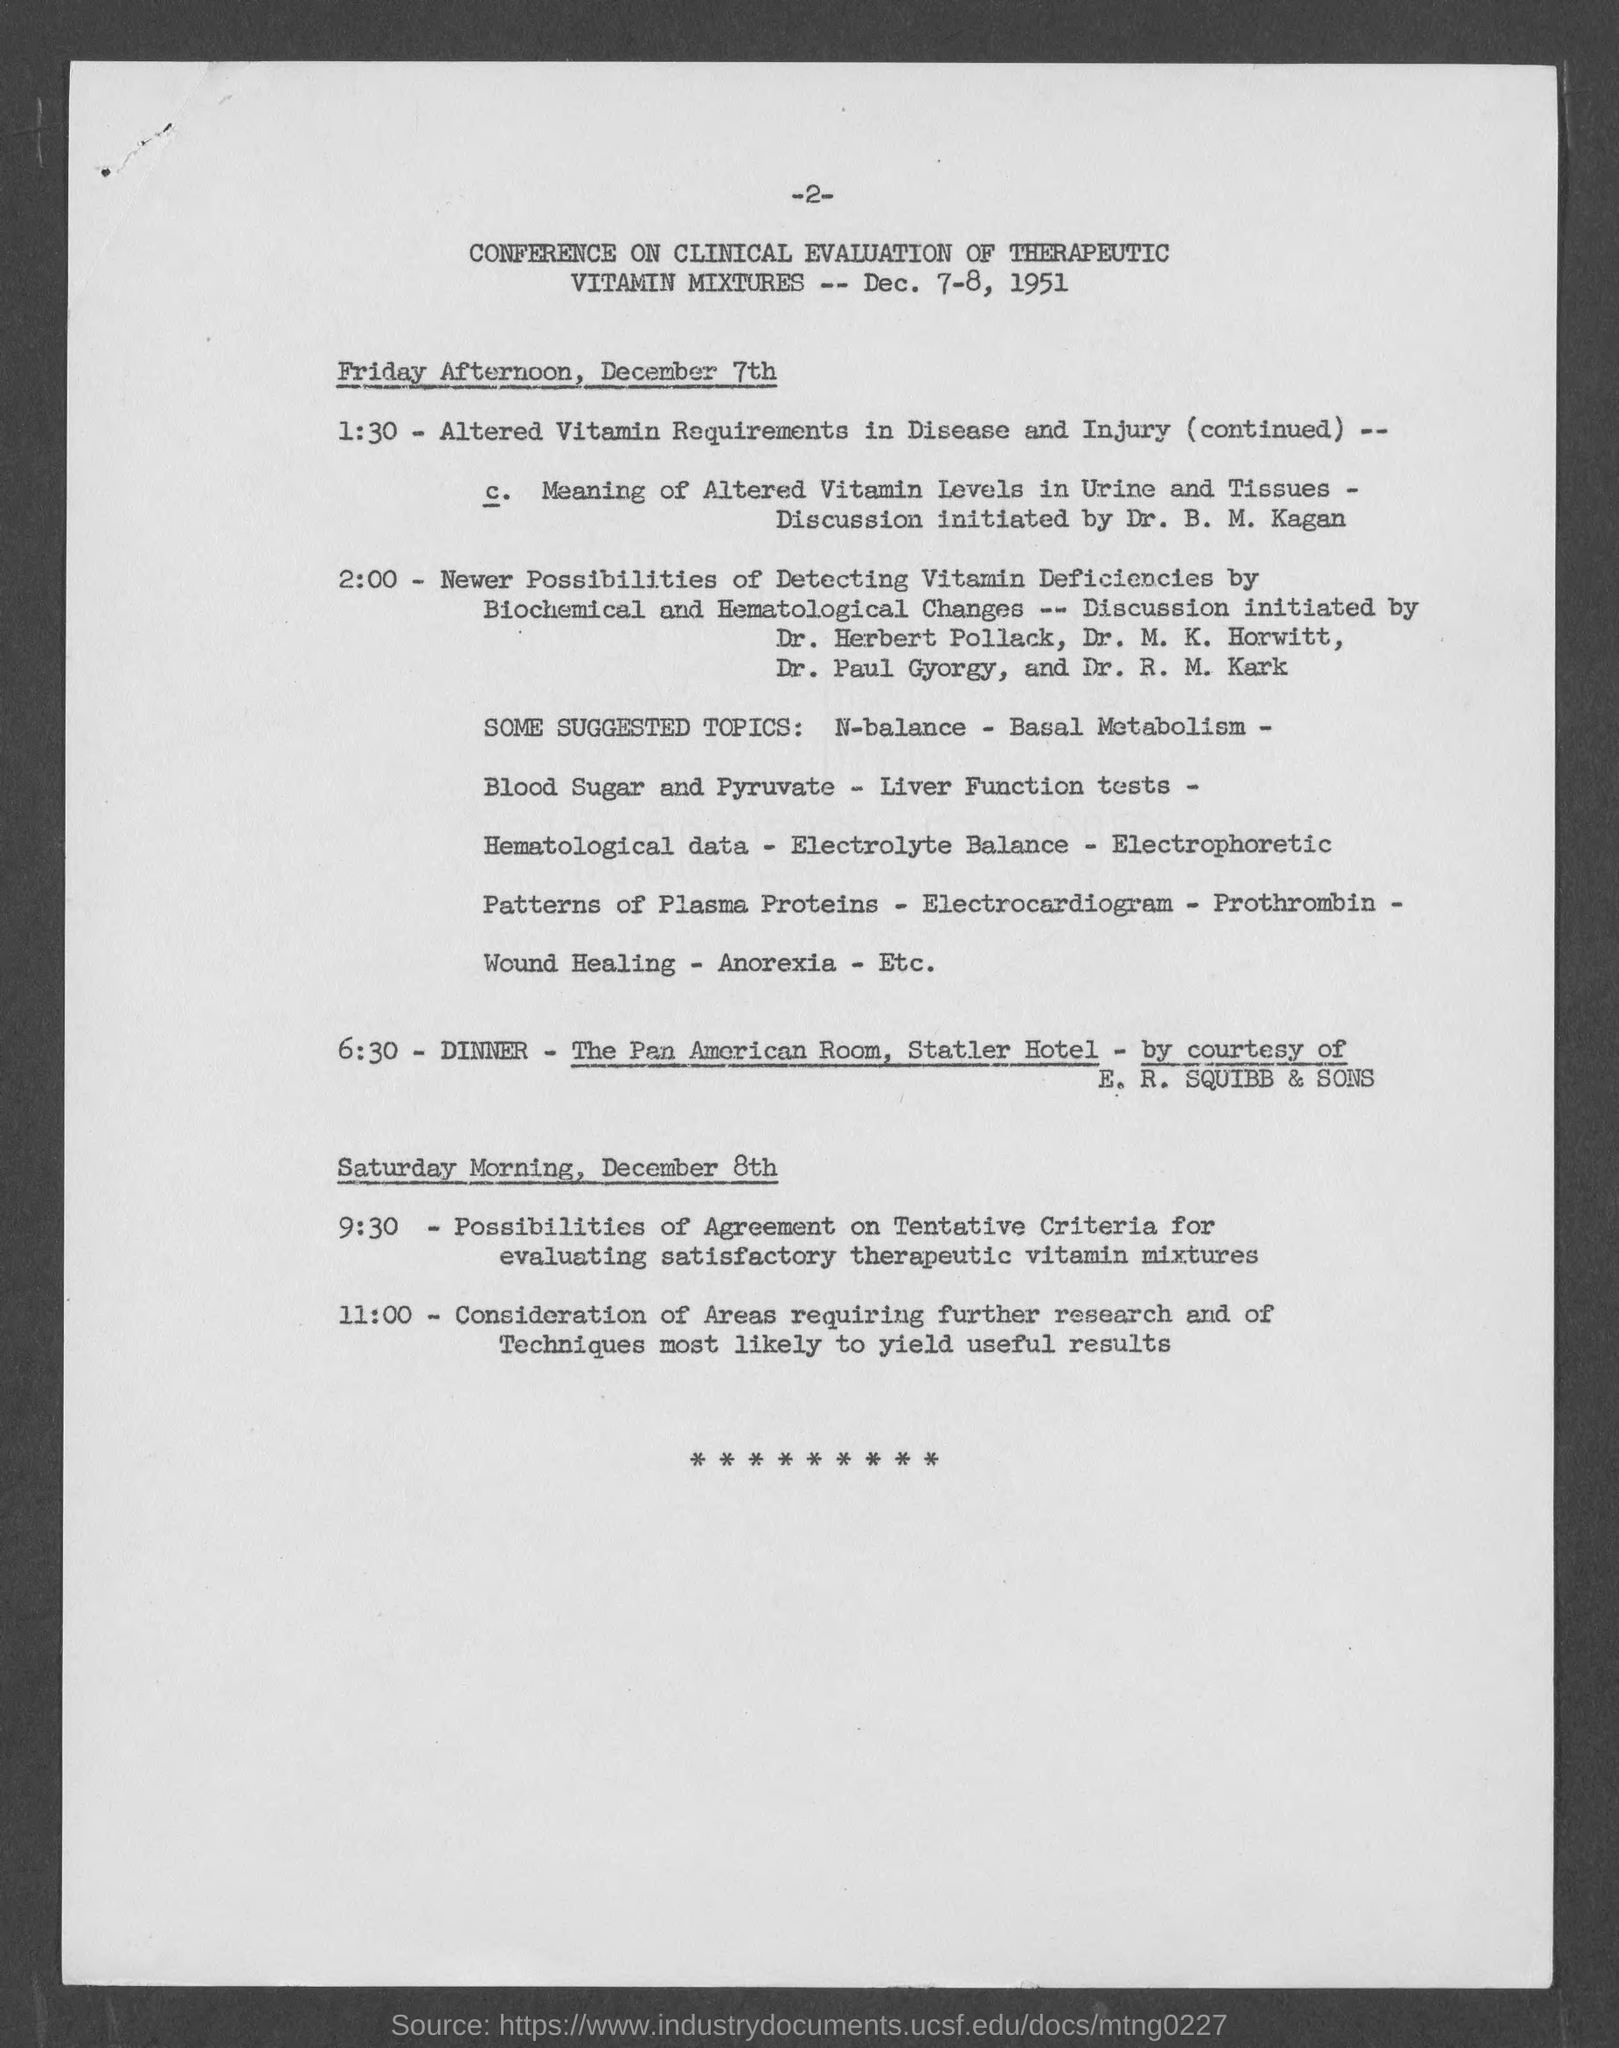What is the conference on?
Keep it short and to the point. Conference on clinical evaluation of therapeutic vitamin mixtures. When is the conference going to be held?
Your answer should be compact. Dec. 7-8, 1951. Where is the dinner going to be?
Offer a terse response. The Pan American Room, Statler Hotel. By whose courtesy is the dinner?
Give a very brief answer. E. R. Squibb & Sons. What is the page number on this document?
Your response must be concise. -2-. 